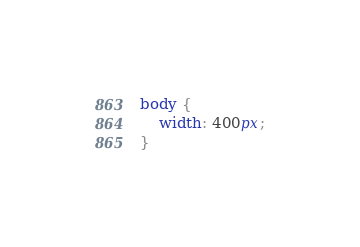<code> <loc_0><loc_0><loc_500><loc_500><_CSS_>body {
	width: 400px;
}
</code> 